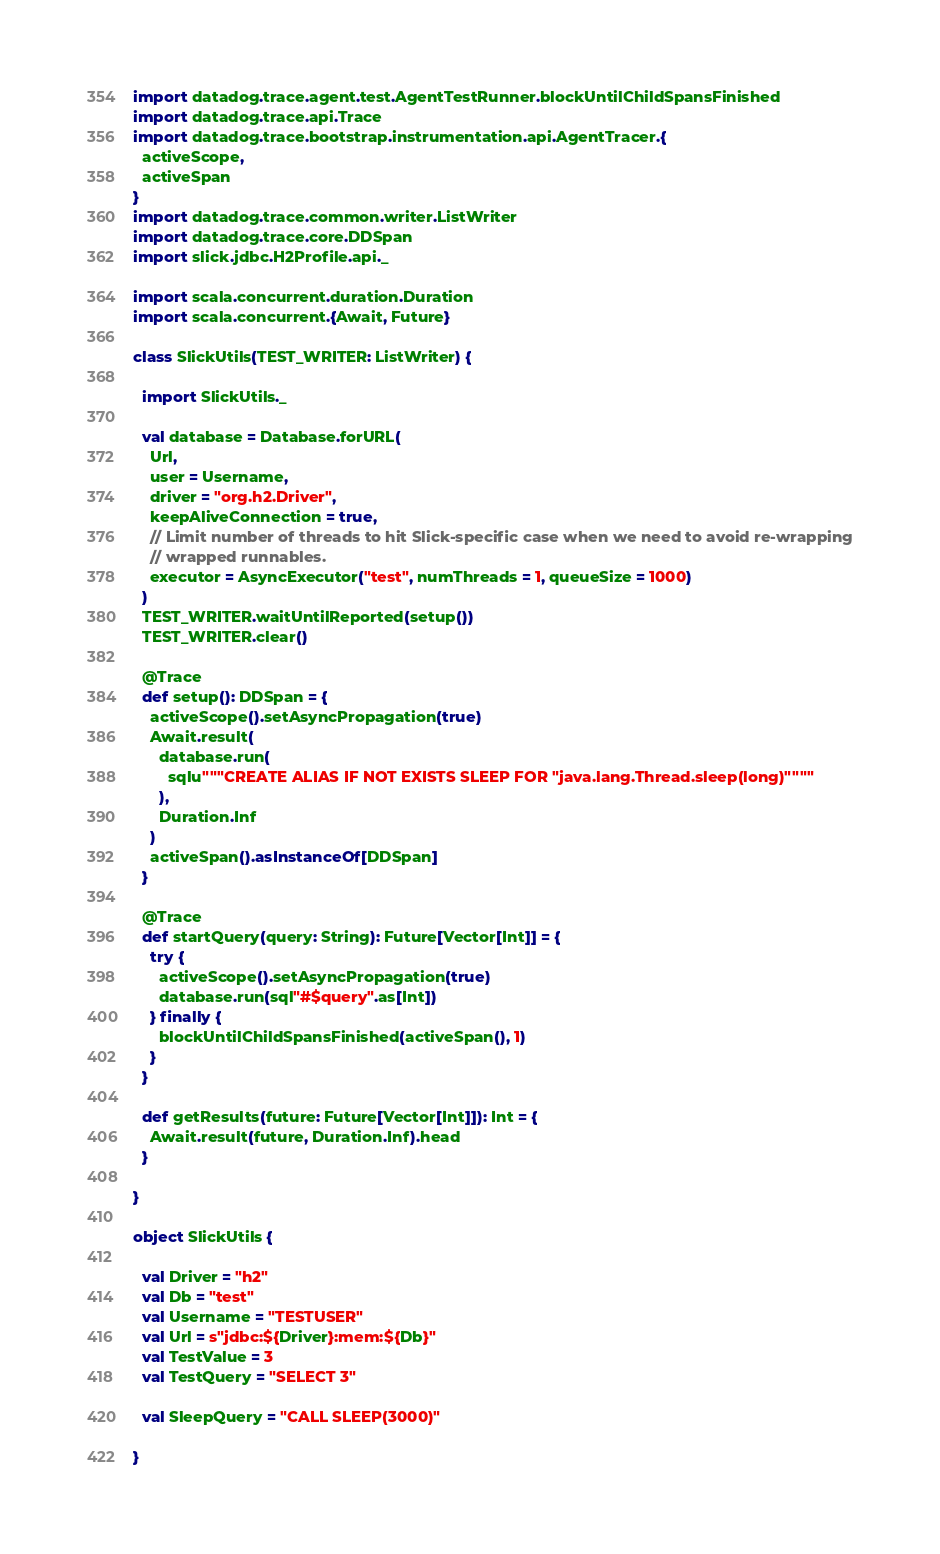<code> <loc_0><loc_0><loc_500><loc_500><_Scala_>import datadog.trace.agent.test.AgentTestRunner.blockUntilChildSpansFinished
import datadog.trace.api.Trace
import datadog.trace.bootstrap.instrumentation.api.AgentTracer.{
  activeScope,
  activeSpan
}
import datadog.trace.common.writer.ListWriter
import datadog.trace.core.DDSpan
import slick.jdbc.H2Profile.api._

import scala.concurrent.duration.Duration
import scala.concurrent.{Await, Future}

class SlickUtils(TEST_WRITER: ListWriter) {

  import SlickUtils._

  val database = Database.forURL(
    Url,
    user = Username,
    driver = "org.h2.Driver",
    keepAliveConnection = true,
    // Limit number of threads to hit Slick-specific case when we need to avoid re-wrapping
    // wrapped runnables.
    executor = AsyncExecutor("test", numThreads = 1, queueSize = 1000)
  )
  TEST_WRITER.waitUntilReported(setup())
  TEST_WRITER.clear()

  @Trace
  def setup(): DDSpan = {
    activeScope().setAsyncPropagation(true)
    Await.result(
      database.run(
        sqlu"""CREATE ALIAS IF NOT EXISTS SLEEP FOR "java.lang.Thread.sleep(long)""""
      ),
      Duration.Inf
    )
    activeSpan().asInstanceOf[DDSpan]
  }

  @Trace
  def startQuery(query: String): Future[Vector[Int]] = {
    try {
      activeScope().setAsyncPropagation(true)
      database.run(sql"#$query".as[Int])
    } finally {
      blockUntilChildSpansFinished(activeSpan(), 1)
    }
  }

  def getResults(future: Future[Vector[Int]]): Int = {
    Await.result(future, Duration.Inf).head
  }

}

object SlickUtils {

  val Driver = "h2"
  val Db = "test"
  val Username = "TESTUSER"
  val Url = s"jdbc:${Driver}:mem:${Db}"
  val TestValue = 3
  val TestQuery = "SELECT 3"

  val SleepQuery = "CALL SLEEP(3000)"

}
</code> 